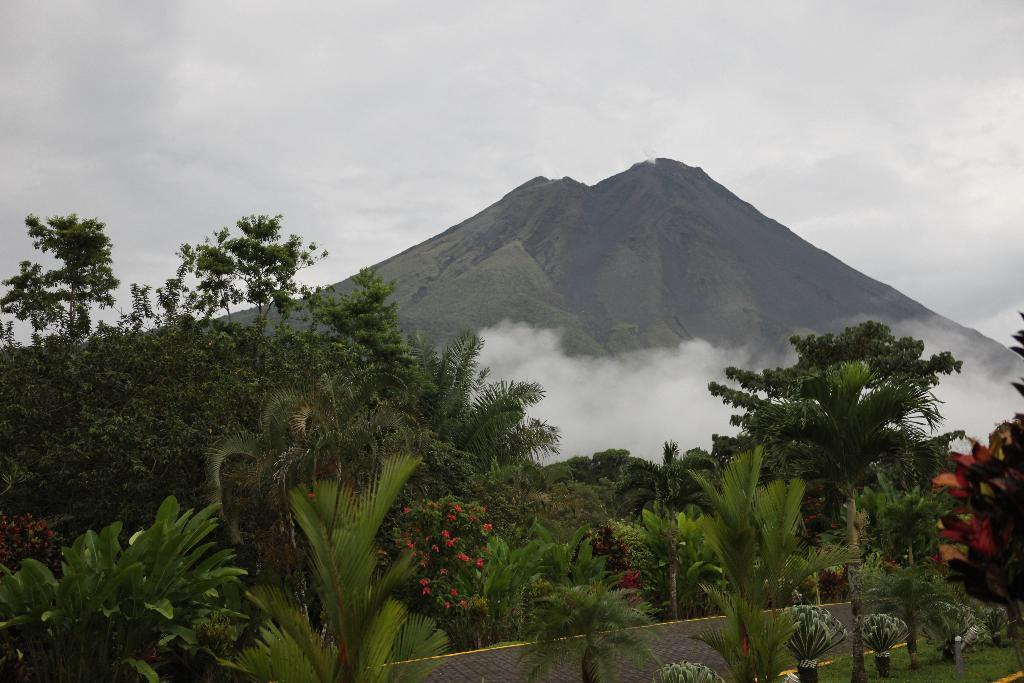What type of vegetation can be seen in the image? There are plants and trees in the image. What is visible in the background of the image? There is a mountain, snow, and the sky visible in the background of the image. What type of page is the fireman reading in the image? There is no fireman or page present in the image. How does the van help with the snow in the image? There is no van present in the image, so it cannot help with the snow. 